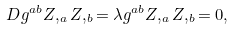<formula> <loc_0><loc_0><loc_500><loc_500>D g ^ { a b } Z , _ { a } Z , _ { b } = \lambda g ^ { a b } Z , _ { a } Z , _ { b } = 0 ,</formula> 